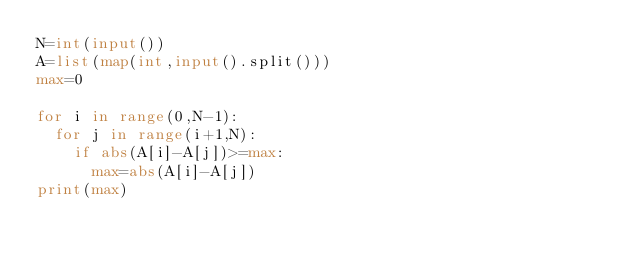Convert code to text. <code><loc_0><loc_0><loc_500><loc_500><_Python_>N=int(input())
A=list(map(int,input().split()))
max=0

for i in range(0,N-1):
  for j in range(i+1,N):
    if abs(A[i]-A[j])>=max:
      max=abs(A[i]-A[j])
print(max)</code> 